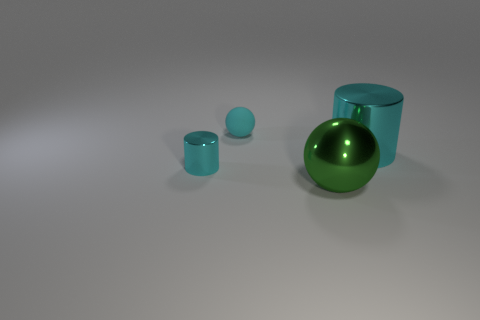What is the size of the green sphere that is made of the same material as the small cyan cylinder?
Your answer should be very brief. Large. Is the shape of the cyan metal object that is in front of the big cyan metallic object the same as  the green metallic thing?
Offer a terse response. No. What size is the other metallic cylinder that is the same color as the tiny cylinder?
Provide a short and direct response. Large. How many blue things are tiny objects or small rubber balls?
Ensure brevity in your answer.  0. What number of other things are there of the same shape as the small shiny thing?
Ensure brevity in your answer.  1. What shape is the cyan object that is both to the left of the big cylinder and in front of the matte object?
Make the answer very short. Cylinder. There is a tiny rubber object; are there any small cyan metal cylinders behind it?
Your answer should be compact. No. What is the size of the other object that is the same shape as the green thing?
Provide a succinct answer. Small. Do the cyan matte object and the large green thing have the same shape?
Offer a very short reply. Yes. There is a metallic object to the left of the large metal object that is in front of the big shiny cylinder; how big is it?
Ensure brevity in your answer.  Small. 